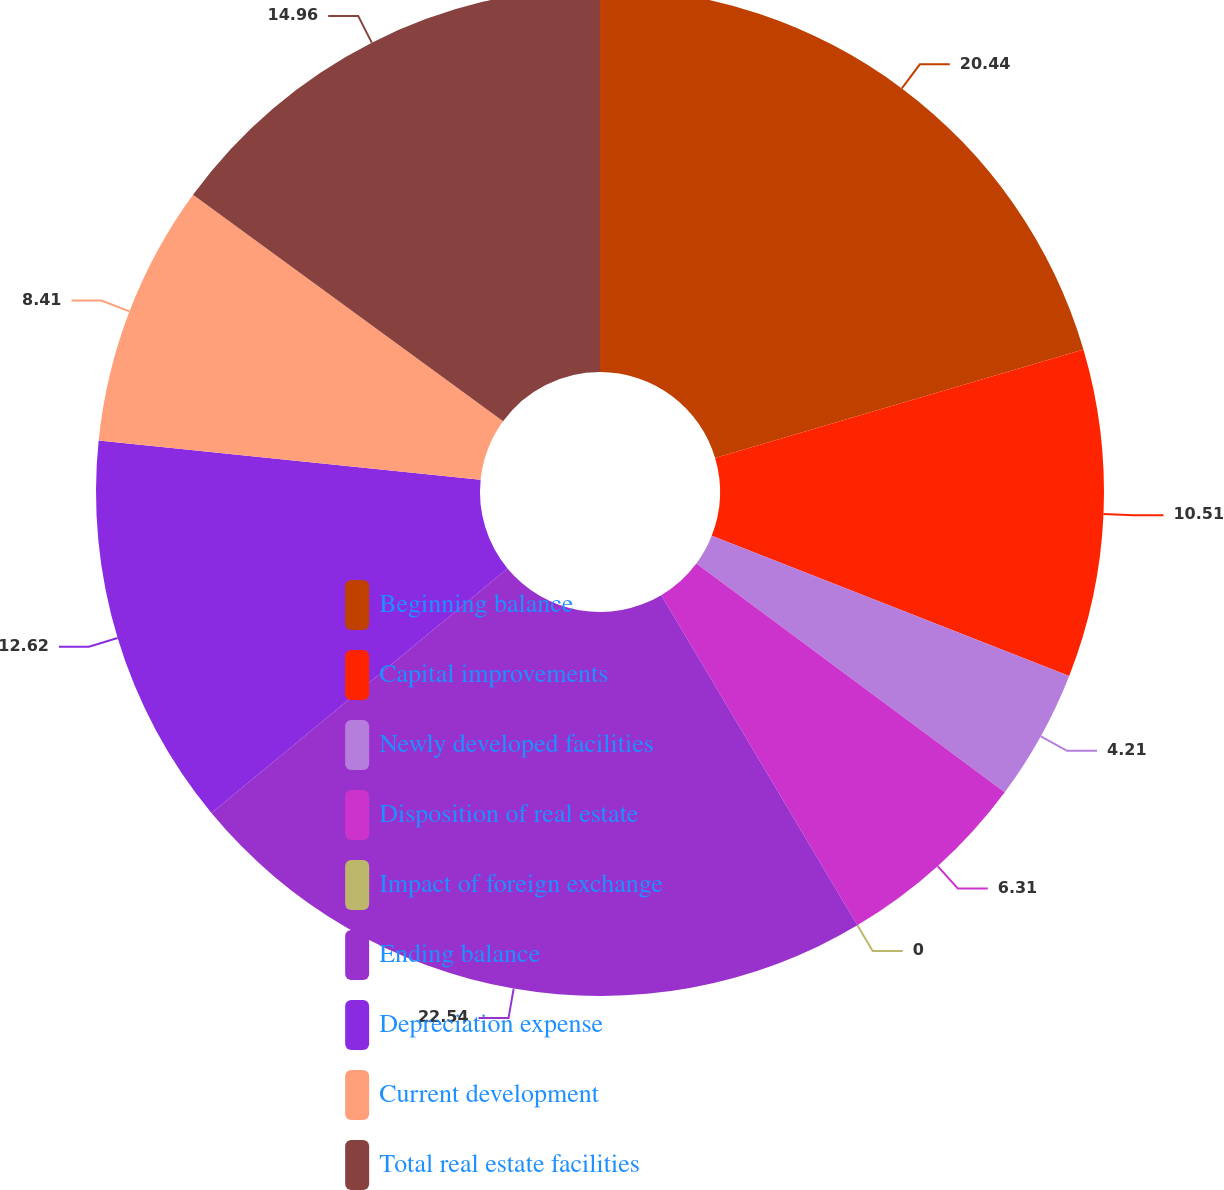Convert chart to OTSL. <chart><loc_0><loc_0><loc_500><loc_500><pie_chart><fcel>Beginning balance<fcel>Capital improvements<fcel>Newly developed facilities<fcel>Disposition of real estate<fcel>Impact of foreign exchange<fcel>Ending balance<fcel>Depreciation expense<fcel>Current development<fcel>Total real estate facilities<nl><fcel>20.44%<fcel>10.51%<fcel>4.21%<fcel>6.31%<fcel>0.0%<fcel>22.54%<fcel>12.62%<fcel>8.41%<fcel>14.96%<nl></chart> 